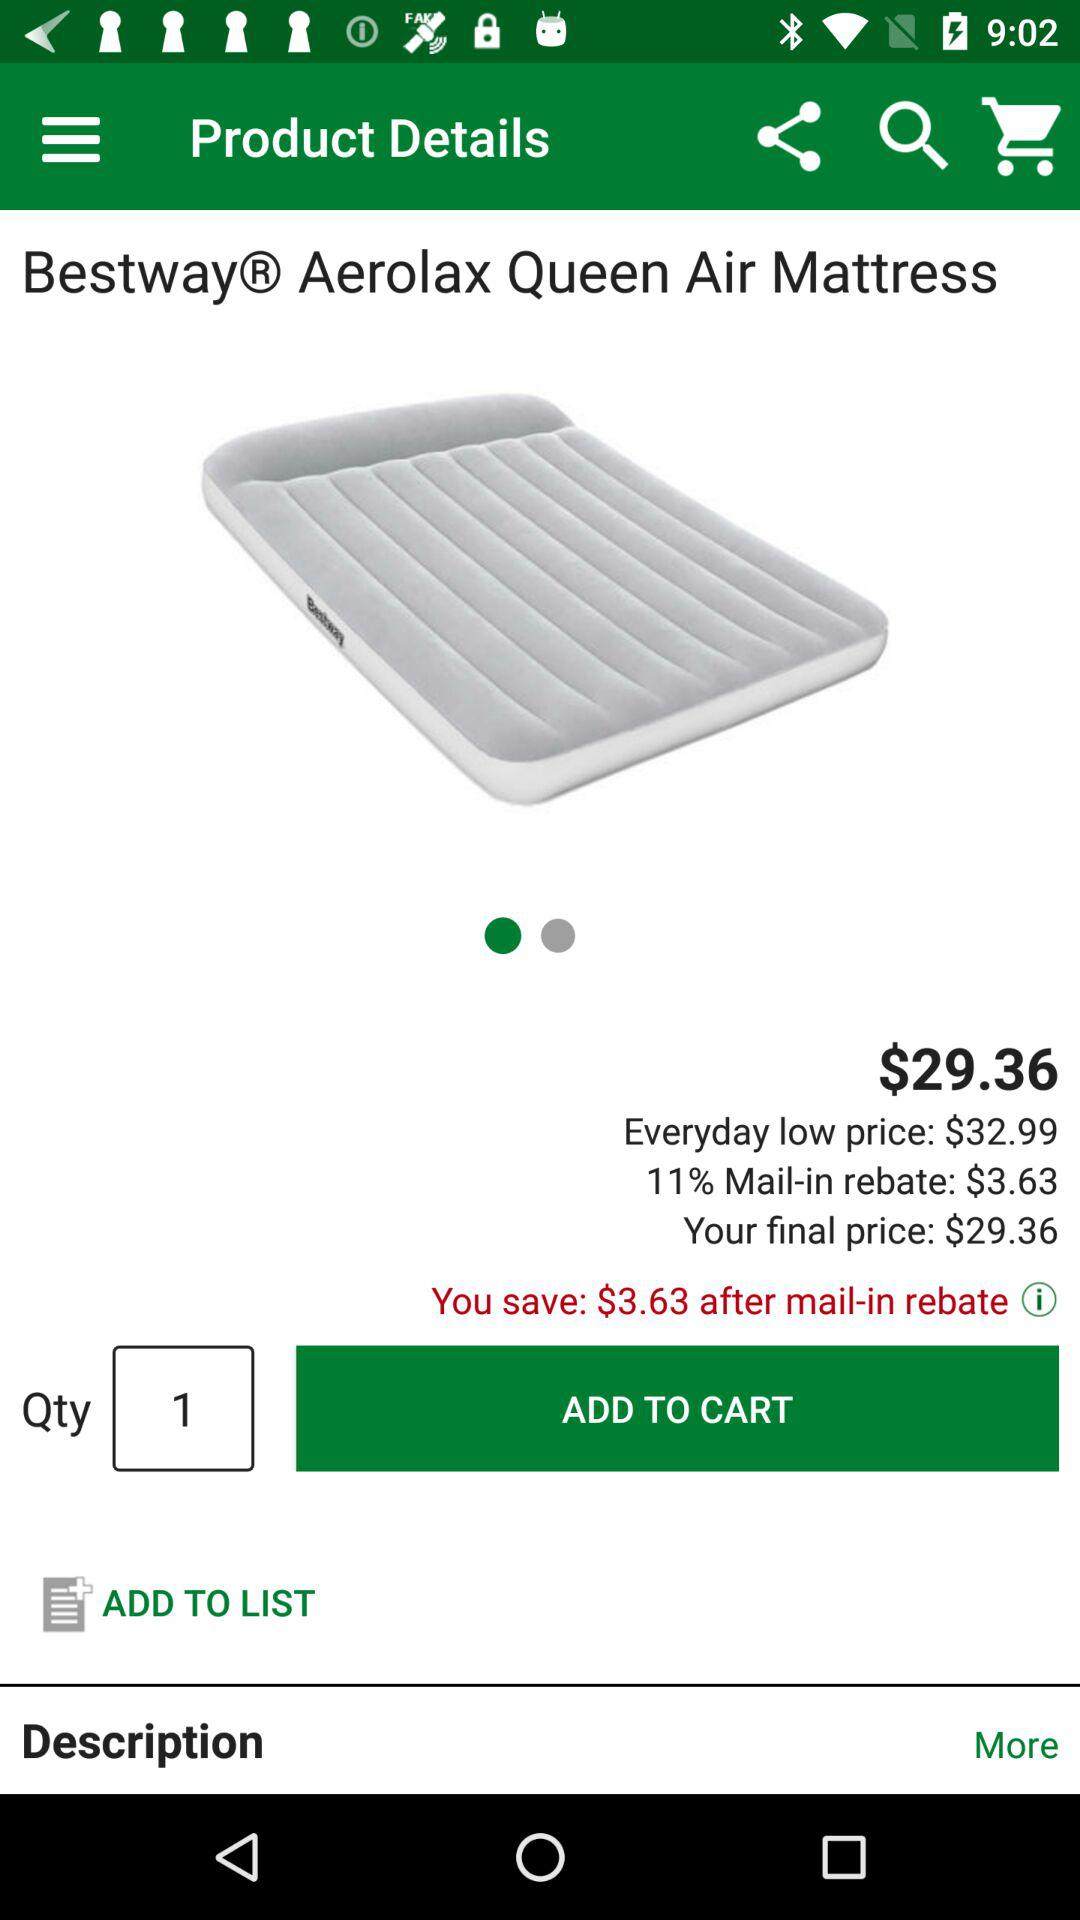What is the quantity of the "Aerolax Queen Air Mattress"? The quantity of the "Aerolax Queen Air Mattress" is 1. 